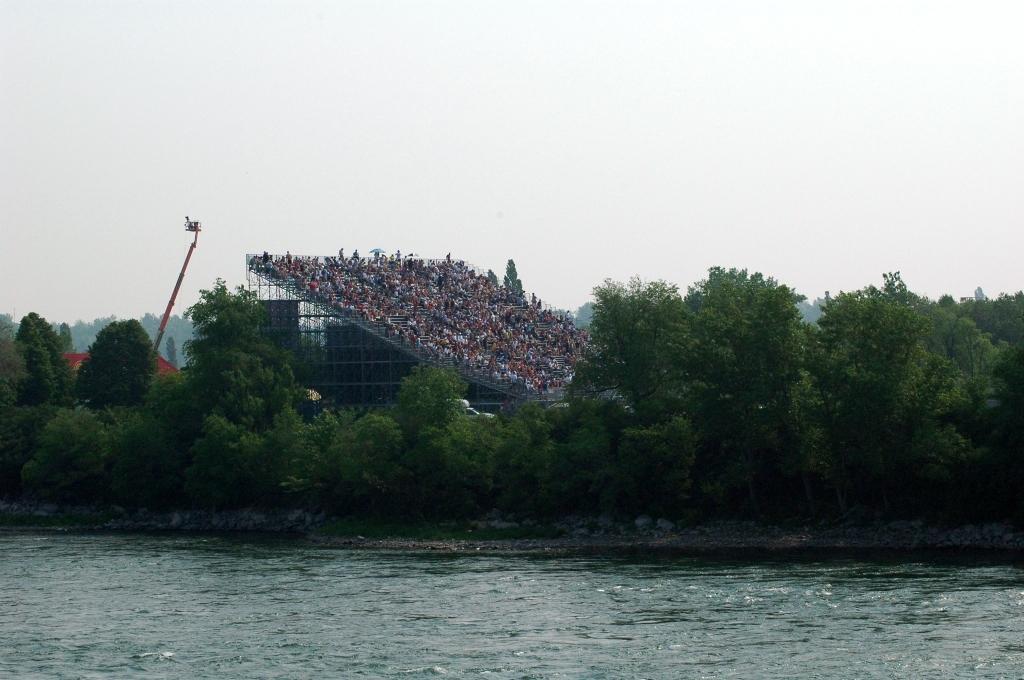In one or two sentences, can you explain what this image depicts? In this image, we can see water, there are some green trees, we can see the crane, at the top we can see the sky. 